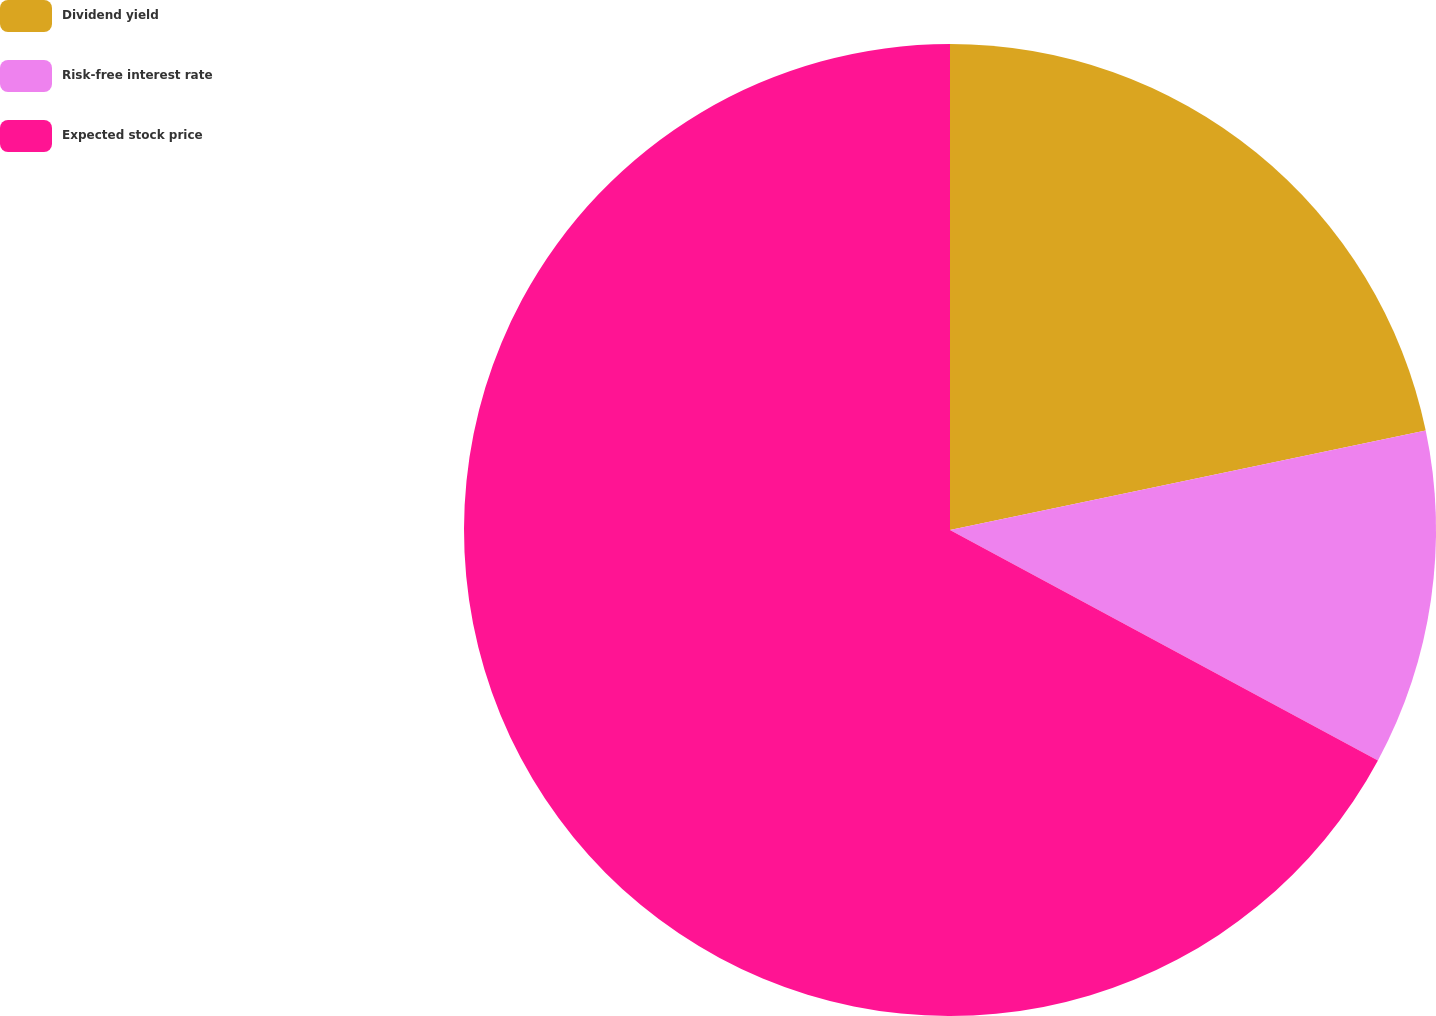Convert chart. <chart><loc_0><loc_0><loc_500><loc_500><pie_chart><fcel>Dividend yield<fcel>Risk-free interest rate<fcel>Expected stock price<nl><fcel>21.72%<fcel>11.14%<fcel>67.14%<nl></chart> 